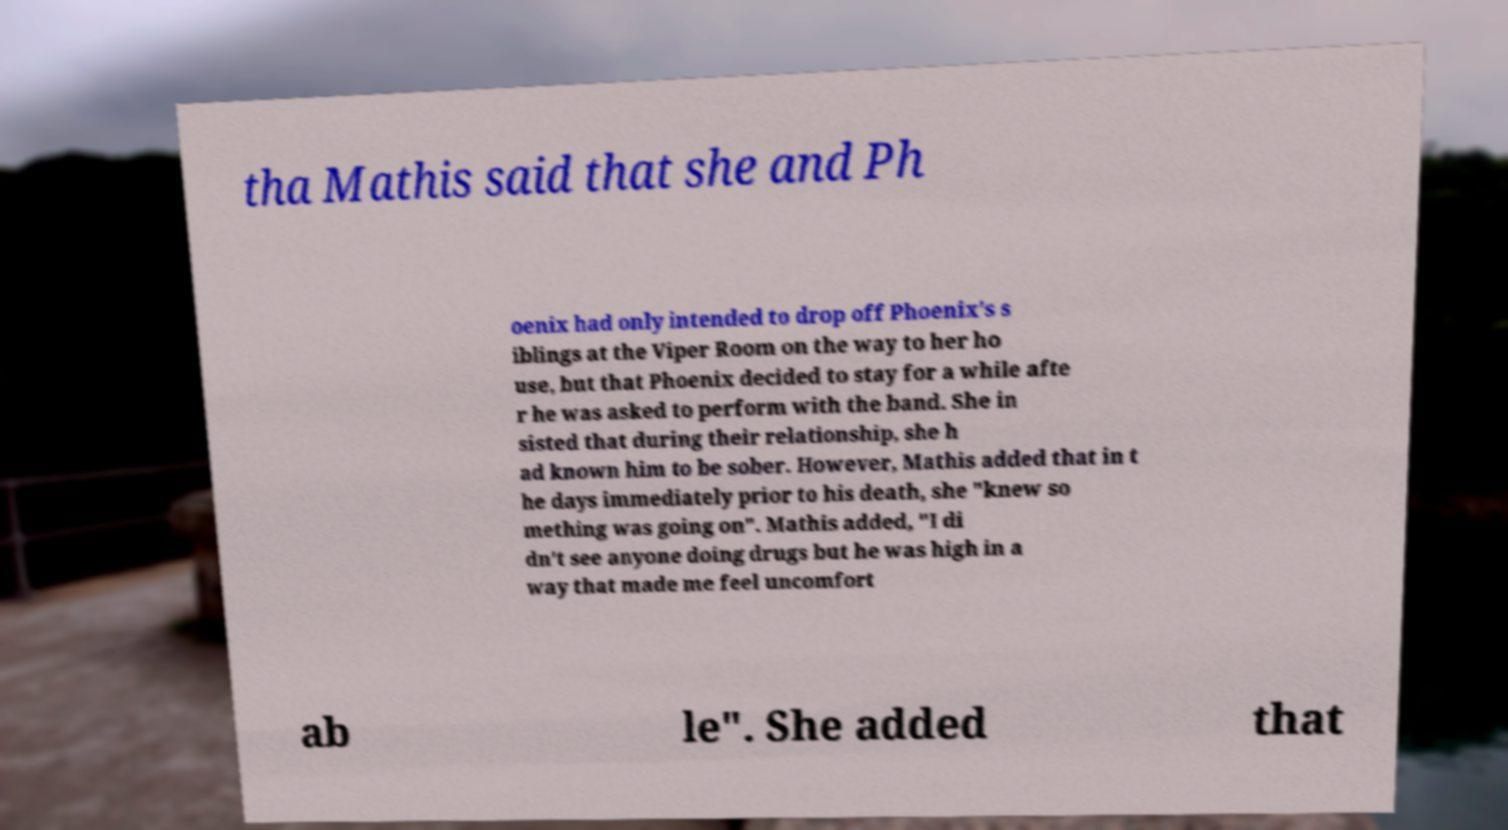There's text embedded in this image that I need extracted. Can you transcribe it verbatim? tha Mathis said that she and Ph oenix had only intended to drop off Phoenix's s iblings at the Viper Room on the way to her ho use, but that Phoenix decided to stay for a while afte r he was asked to perform with the band. She in sisted that during their relationship, she h ad known him to be sober. However, Mathis added that in t he days immediately prior to his death, she "knew so mething was going on". Mathis added, "I di dn't see anyone doing drugs but he was high in a way that made me feel uncomfort ab le". She added that 